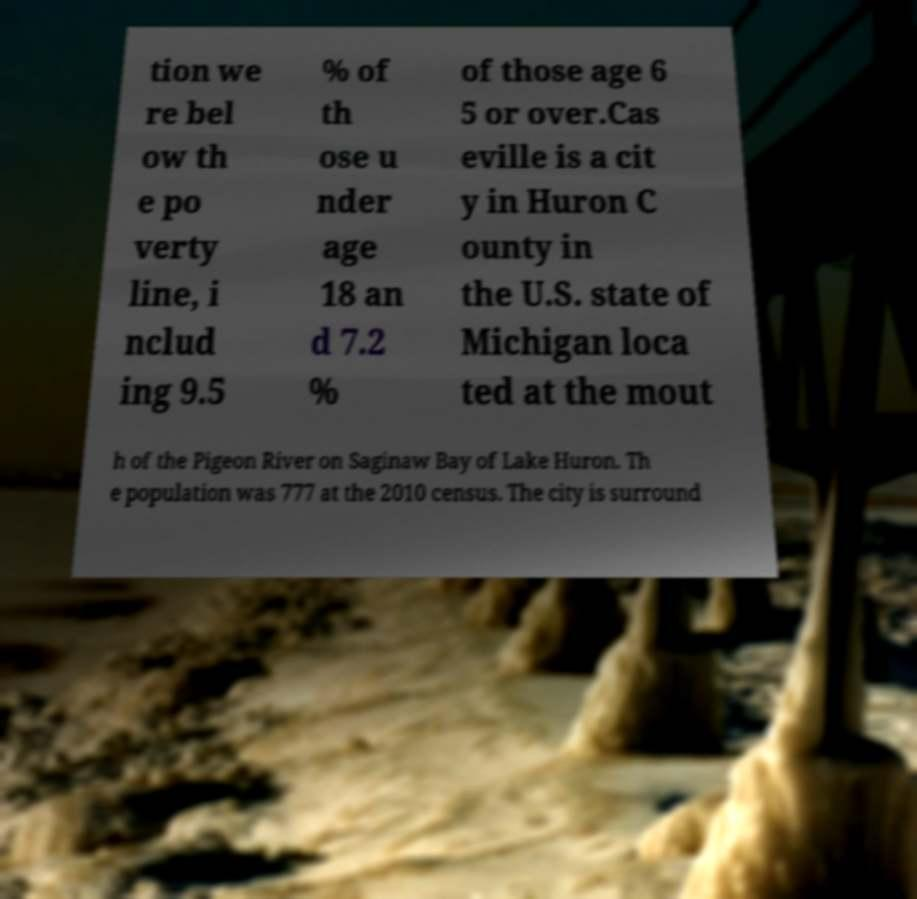For documentation purposes, I need the text within this image transcribed. Could you provide that? tion we re bel ow th e po verty line, i nclud ing 9.5 % of th ose u nder age 18 an d 7.2 % of those age 6 5 or over.Cas eville is a cit y in Huron C ounty in the U.S. state of Michigan loca ted at the mout h of the Pigeon River on Saginaw Bay of Lake Huron. Th e population was 777 at the 2010 census. The city is surround 